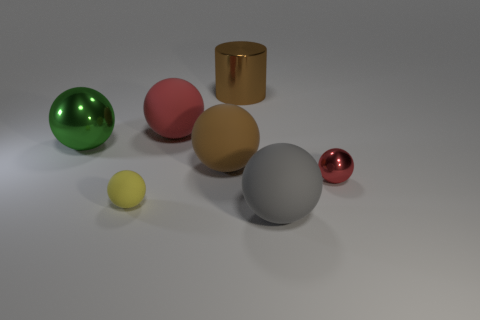Subtract all yellow balls. How many balls are left? 5 Subtract all gray spheres. How many spheres are left? 5 Subtract all blue spheres. Subtract all green cylinders. How many spheres are left? 6 Add 1 tiny cyan matte cylinders. How many objects exist? 8 Subtract all cylinders. How many objects are left? 6 Subtract all large brown cylinders. Subtract all brown rubber balls. How many objects are left? 5 Add 3 red shiny spheres. How many red shiny spheres are left? 4 Add 5 brown metal cylinders. How many brown metal cylinders exist? 6 Subtract 0 gray cylinders. How many objects are left? 7 